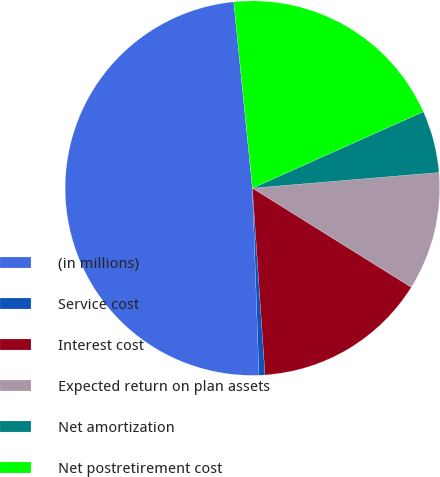Convert chart. <chart><loc_0><loc_0><loc_500><loc_500><pie_chart><fcel>(in millions)<fcel>Service cost<fcel>Interest cost<fcel>Expected return on plan assets<fcel>Net amortization<fcel>Net postretirement cost<nl><fcel>48.97%<fcel>0.51%<fcel>15.05%<fcel>10.21%<fcel>5.36%<fcel>19.9%<nl></chart> 